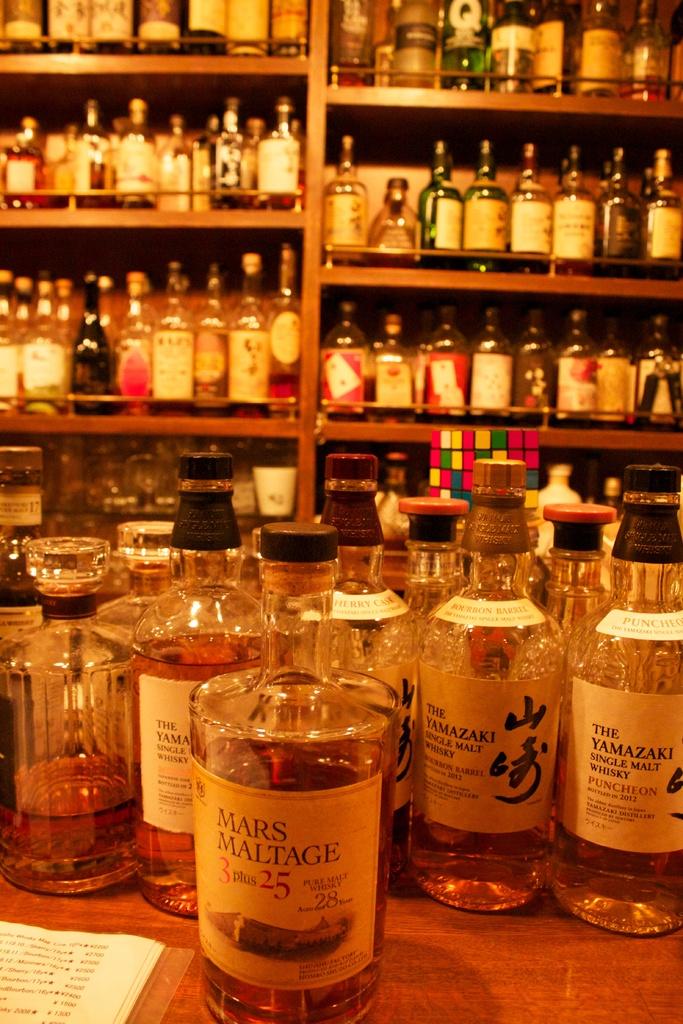What is the first number on the bottle in front?
Your answer should be compact. 3. 